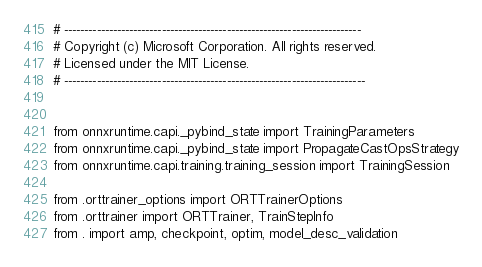<code> <loc_0><loc_0><loc_500><loc_500><_Python_># -------------------------------------------------------------------------
# Copyright (c) Microsoft Corporation. All rights reserved.
# Licensed under the MIT License.
# --------------------------------------------------------------------------


from onnxruntime.capi._pybind_state import TrainingParameters
from onnxruntime.capi._pybind_state import PropagateCastOpsStrategy
from onnxruntime.capi.training.training_session import TrainingSession

from .orttrainer_options import ORTTrainerOptions
from .orttrainer import ORTTrainer, TrainStepInfo
from . import amp, checkpoint, optim, model_desc_validation
</code> 